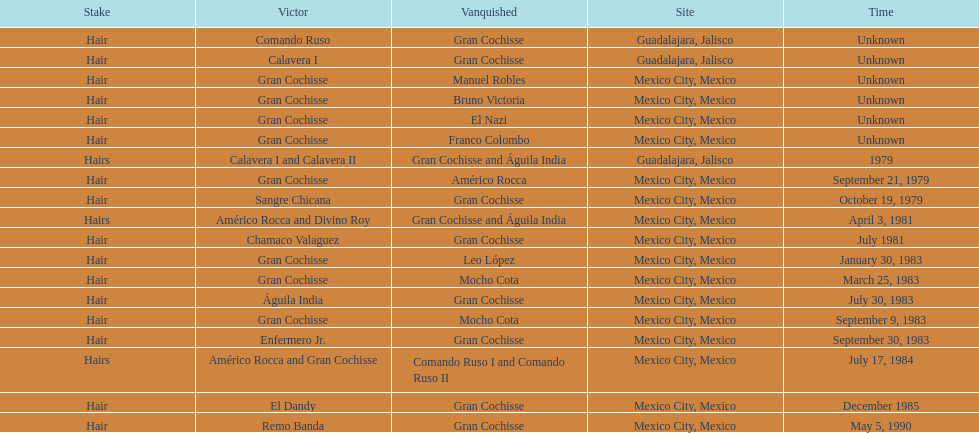How many times has gran cochisse been a winner? 9. 